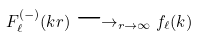Convert formula to latex. <formula><loc_0><loc_0><loc_500><loc_500>F _ { \ell } ^ { ( - ) } ( k r ) \longrightarrow _ { r \to \infty } f _ { \ell } ( k )</formula> 